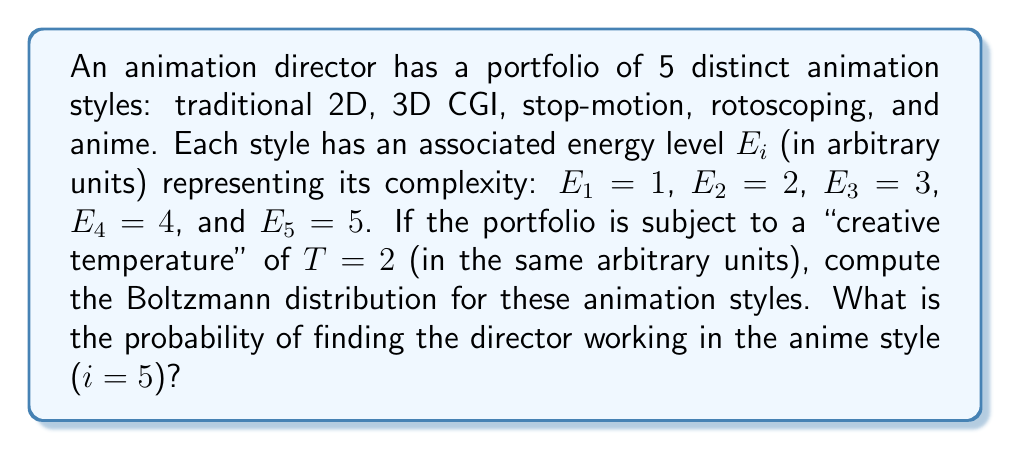What is the answer to this math problem? To solve this problem, we'll use the Boltzmann distribution formula and follow these steps:

1) The Boltzmann distribution is given by:

   $$P_i = \frac{e^{-E_i/kT}}{\sum_{j=1}^N e^{-E_j/kT}}$$

   where $P_i$ is the probability of state i, $E_i$ is the energy of state i, $k$ is Boltzmann's constant (which we'll take as 1 in our arbitrary units), $T$ is the temperature, and $N$ is the total number of states.

2) First, let's calculate the denominator (partition function):

   $$Z = \sum_{j=1}^N e^{-E_j/kT} = e^{-1/2} + e^{-2/2} + e^{-3/2} + e^{-4/2} + e^{-5/2}$$

3) Using a calculator or computer:

   $$Z \approx 0.6065 + 0.3679 + 0.2231 + 0.1353 + 0.0821 \approx 1.4149$$

4) Now, for the anime style (i = 5), we calculate:

   $$P_5 = \frac{e^{-E_5/kT}}{Z} = \frac{e^{-5/2}}{1.4149}$$

5) Evaluating this:

   $$P_5 \approx \frac{0.0821}{1.4149} \approx 0.0580$$

6) Converting to a percentage:

   $$P_5 \approx 5.80\%$$
Answer: 5.80% 